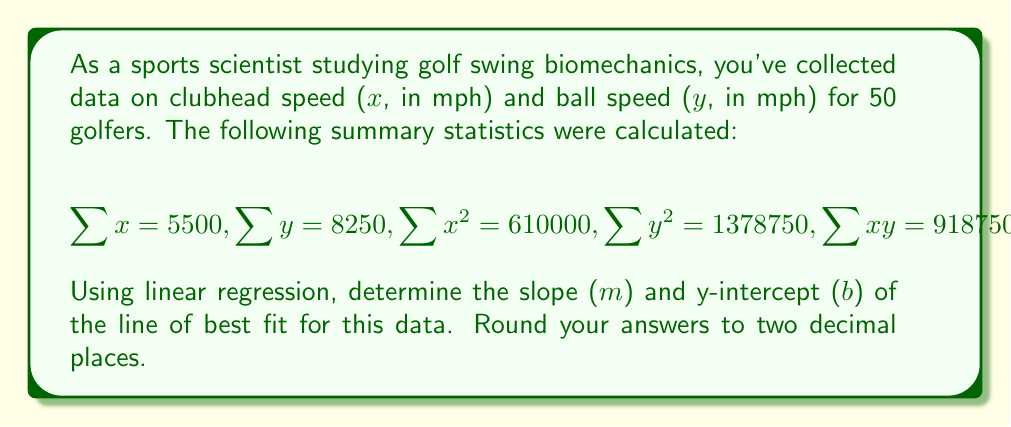Can you solve this math problem? To find the slope (m) and y-intercept (b) of the line of best fit using linear regression, we'll use the following formulas:

1. Slope (m):
   $$m = \frac{n\sum xy - \sum x \sum y}{n\sum x^2 - (\sum x)^2}$$

2. Y-intercept (b):
   $$b = \frac{\sum y - m\sum x}{n}$$

Where n is the number of data points (50 in this case).

Step 1: Calculate the slope (m)
$$\begin{aligned}
m &= \frac{50(918750) - (5500)(8250)}{50(610000) - (5500)^2} \\
&= \frac{45937500 - 45375000}{30500000 - 30250000} \\
&= \frac{562500}{250000} \\
&= 2.25
\end{aligned}$$

Step 2: Calculate the y-intercept (b)
$$\begin{aligned}
b &= \frac{8250 - 2.25(5500)}{50} \\
&= \frac{8250 - 12375}{50} \\
&= \frac{-4125}{50} \\
&= -82.5
\end{aligned}$$

Therefore, the equation of the line of best fit is:
$$y = 2.25x - 82.5$$

Rounding to two decimal places:
Slope (m) = 2.25
Y-intercept (b) = -82.50
Answer: m = 2.25, b = -82.50 